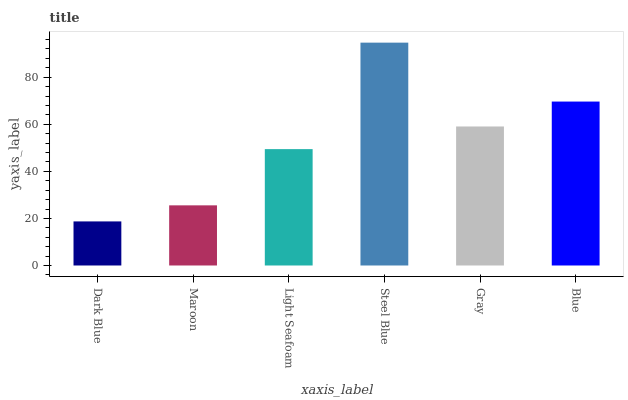Is Dark Blue the minimum?
Answer yes or no. Yes. Is Steel Blue the maximum?
Answer yes or no. Yes. Is Maroon the minimum?
Answer yes or no. No. Is Maroon the maximum?
Answer yes or no. No. Is Maroon greater than Dark Blue?
Answer yes or no. Yes. Is Dark Blue less than Maroon?
Answer yes or no. Yes. Is Dark Blue greater than Maroon?
Answer yes or no. No. Is Maroon less than Dark Blue?
Answer yes or no. No. Is Gray the high median?
Answer yes or no. Yes. Is Light Seafoam the low median?
Answer yes or no. Yes. Is Dark Blue the high median?
Answer yes or no. No. Is Blue the low median?
Answer yes or no. No. 